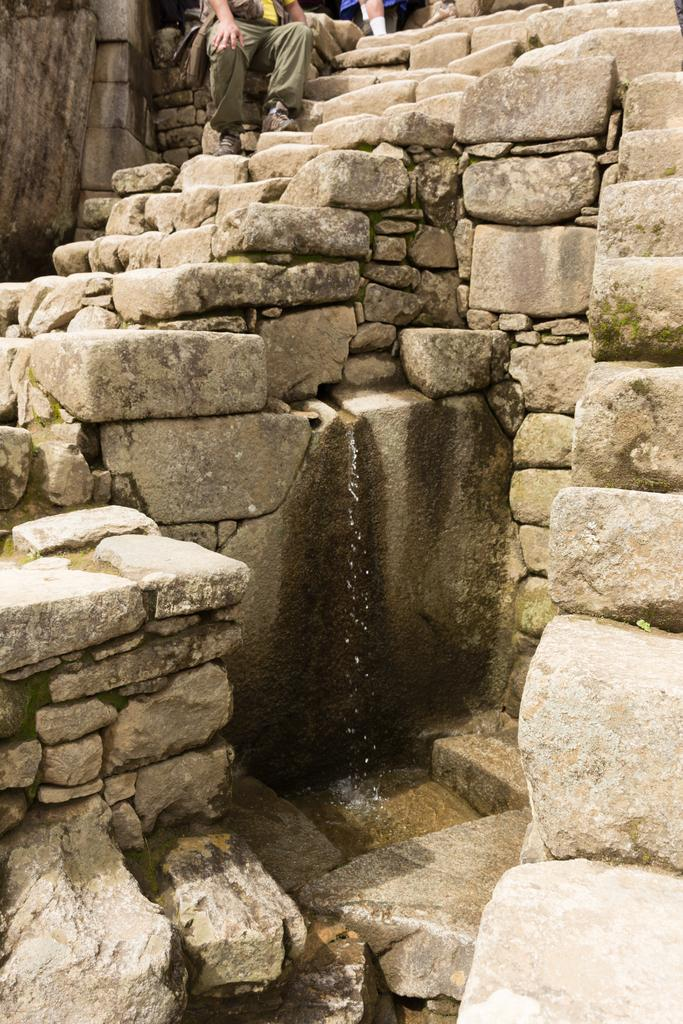What type of natural formation can be seen in the image? There are rocks in the image. What is happening to the rocks in the image? Water is falling from the rocks. Can you describe the people in the background of the image? There are people with different color dresses in the background of the image. What grade does the tree in the image belong to? There is no tree present in the image, so it is not possible to determine the grade of a tree. 